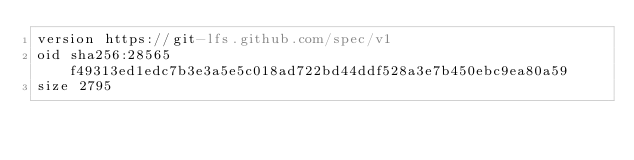<code> <loc_0><loc_0><loc_500><loc_500><_YAML_>version https://git-lfs.github.com/spec/v1
oid sha256:28565f49313ed1edc7b3e3a5e5c018ad722bd44ddf528a3e7b450ebc9ea80a59
size 2795
</code> 